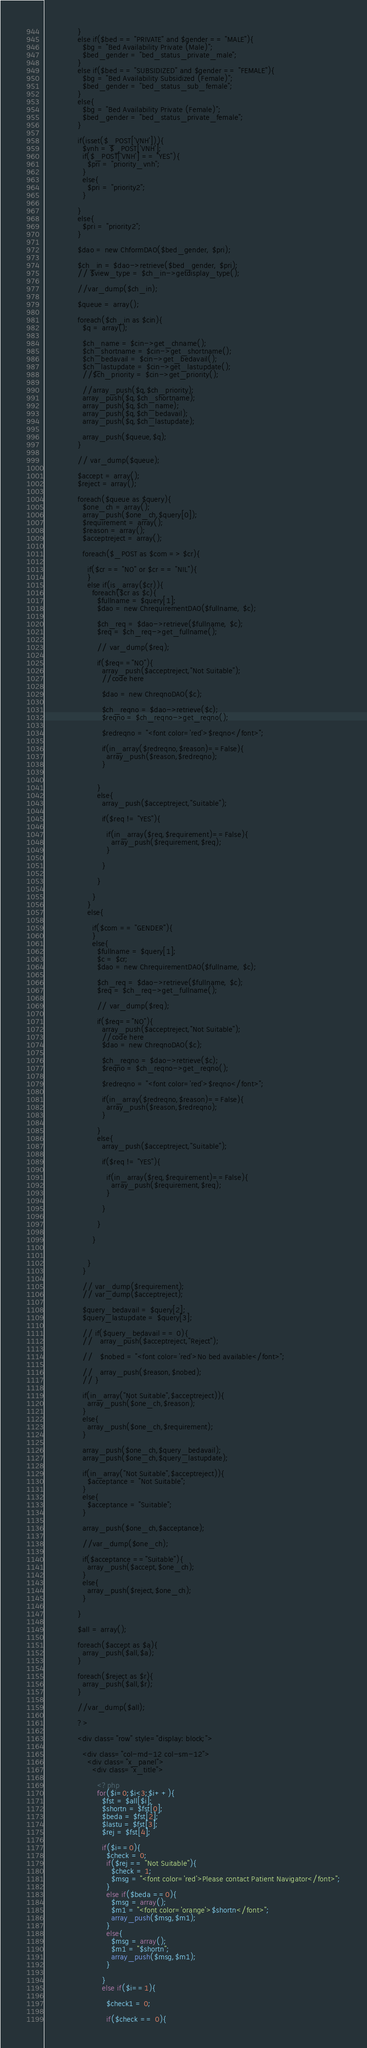Convert code to text. <code><loc_0><loc_0><loc_500><loc_500><_PHP_>              }
              else if($bed == "PRIVATE" and $gender == "MALE"){
                $bg = "Bed Availability Private (Male)";
                $bed_gender = "bed_status_private_male";
              }
              else if($bed == "SUBSIDIZED" and $gender == "FEMALE"){
                $bg = "Bed Availability Subsidized (Female)";
                $bed_gender = "bed_status_sub_female";
              }
              else{
                $bg = "Bed Availability Private (Female)";
                $bed_gender = "bed_status_private_female";
              }

              if(isset($_POST['VNH'])){
                $vnh = $_POST['VNH'];
                if($_POST['VNH'] == "YES"){
                  $pri = "priority_vnh";
                }
                else{
                  $pri = "priority2";
                }
                
              }
              else{
                $pri = "priority2";
              }

              $dao = new ChformDAO($bed_gender, $pri);

              $ch_in = $dao->retrieve($bed_gender, $pri);
              // $view_type = $ch_in->getdisplay_type();

              //var_dump($ch_in);

              $queue = array();

              foreach($ch_in as $cin){
                $q = array();

                $ch_name = $cin->get_chname();
                $ch_shortname = $cin->get_shortname();
                $ch_bedavail = $cin->get_bedavail();
                $ch_lastupdate = $cin->get_lastupdate();
                //$ch_priority = $cin->get_priority();

                //array_push($q,$ch_priority);
                array_push($q,$ch_shortname);
                array_push($q,$ch_name);
                array_push($q,$ch_bedavail);
                array_push($q,$ch_lastupdate);

                array_push($queue,$q);
              }

              // var_dump($queue);

              $accept = array();
              $reject = array();

              foreach($queue as $query){
                $one_ch = array();
                array_push($one_ch,$query[0]);
                $requirement = array();
                $reason = array();
                $acceptreject = array();

                foreach($_POST as $com => $cr){

                  if($cr == "NO" or $cr == "NIL"){
                  }
                  else if(is_array($cr)){
                    foreach($cr as $c){
                      $fullname = $query[1];
                      $dao = new ChrequirementDAO($fullname, $c);

                      $ch_req = $dao->retrieve($fullname, $c);
                      $req = $ch_req->get_fullname();

                      // var_dump($req);

                      if($req=="NO"){
                        array_push($acceptreject,"Not Suitable");
                        //code here

                        $dao = new ChreqnoDAO($c);

                        $ch_reqno = $dao->retrieve($c);
                        $reqno = $ch_reqno->get_reqno();

                        $redreqno = "<font color='red'>$reqno</font>";

                        if(in_array($redreqno,$reason)==False){
                          array_push($reason,$redreqno);
                        }
                        

                      }
                      else{
                        array_push($acceptreject,"Suitable");

                        if($req != "YES"){

                          if(in_array($req,$requirement)==False){
                            array_push($requirement,$req);
                          }
                          
                        }
                        
                      }

                    }
                  }
                  else{

                    if($com == "GENDER"){
                    }
                    else{
                      $fullname = $query[1];
                      $c = $cr;
                      $dao = new ChrequirementDAO($fullname, $c);

                      $ch_req = $dao->retrieve($fullname, $c);
                      $req = $ch_req->get_fullname();

                      // var_dump($req);

                      if($req=="NO"){
                        array_push($acceptreject,"Not Suitable");
                        //code here
                        $dao = new ChreqnoDAO($c);

                        $ch_reqno = $dao->retrieve($c);
                        $reqno = $ch_reqno->get_reqno();

                        $redreqno = "<font color='red'>$reqno</font>";

                        if(in_array($redreqno,$reason)==False){
                          array_push($reason,$redreqno);
                        }

                      }
                      else{
                        array_push($acceptreject,"Suitable");

                        if($req != "YES"){

                          if(in_array($req,$requirement)==False){
                            array_push($requirement,$req);
                          }

                        }
                        
                      }

                    }


                  }
                }

                // var_dump($requirement);
                // var_dump($acceptreject);

                $query_bedavail = $query[2];
                $query_lastupdate = $query[3];
                
                // if($query_bedavail == 0){
                //   array_push($acceptreject,"Reject");

                //   $nobed = "<font color='red'>No bed available</font>";

                //   array_push($reason,$nobed);
                // }

                if(in_array("Not Suitable",$acceptreject)){
                  array_push($one_ch,$reason);
                }
                else{
                  array_push($one_ch,$requirement);
                }

                array_push($one_ch,$query_bedavail);
                array_push($one_ch,$query_lastupdate);

                if(in_array("Not Suitable",$acceptreject)){
                  $acceptance = "Not Suitable";
                }
                else{
                  $acceptance = "Suitable";
                }

                array_push($one_ch,$acceptance);

                //var_dump($one_ch);

                if($acceptance =="Suitable"){
                  array_push($accept,$one_ch);
                }
                else{
                  array_push($reject,$one_ch);
                }

              }
              
              $all = array();

              foreach($accept as $a){
                array_push($all,$a);
              }

              foreach($reject as $r){
                array_push($all,$r);
              }

              //var_dump($all);

              ?>

              <div class="row" style="display: block;">

                <div class="col-md-12 col-sm-12">
                  <div class="x_panel">
                    <div class="x_title">

                      <?php
                      for($i=0;$i<3;$i++){
                        $fst = $all[$i];
                        $shortn = $fst[0];
                        $beda = $fst[2];
                        $lastu = $fst[3];
                        $rej = $fst[4]; 

                        if($i==0){
                          $check = 0;
                          if($rej == "Not Suitable"){
                            $check = 1;
                            $msg = "<font color='red'>Please contact Patient Navigator</font>";
                          }
                          else if($beda ==0){
                            $msg = array();
                            $m1 = "<font color='orange'>$shortn</font>";
                            array_push($msg,$m1);
                          }
                          else{
                            $msg = array();
                            $m1 = "$shortn";
                            array_push($msg,$m1);
                          }
                          
                        }
                        else if($i==1){

                          $check1 = 0;

                          if($check == 0){</code> 